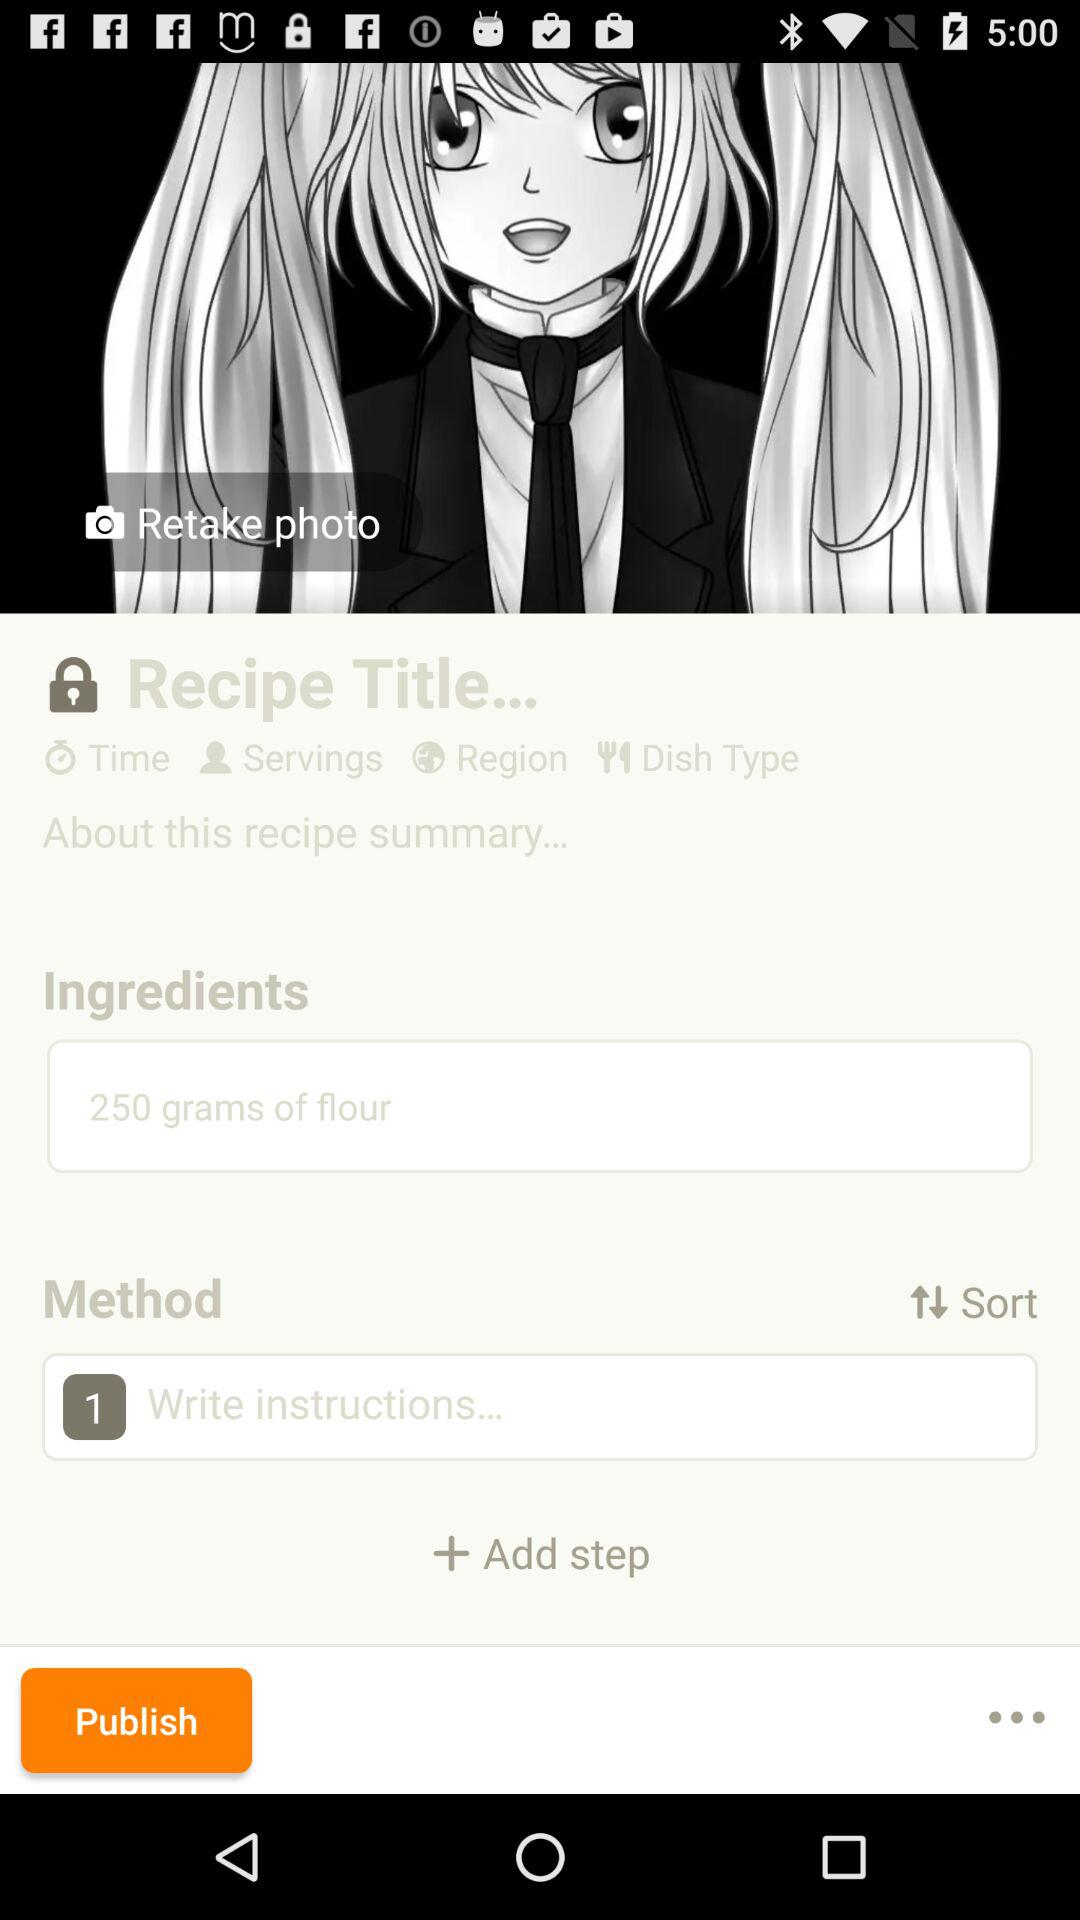How many more ingredients are there than steps?
Answer the question using a single word or phrase. 1 